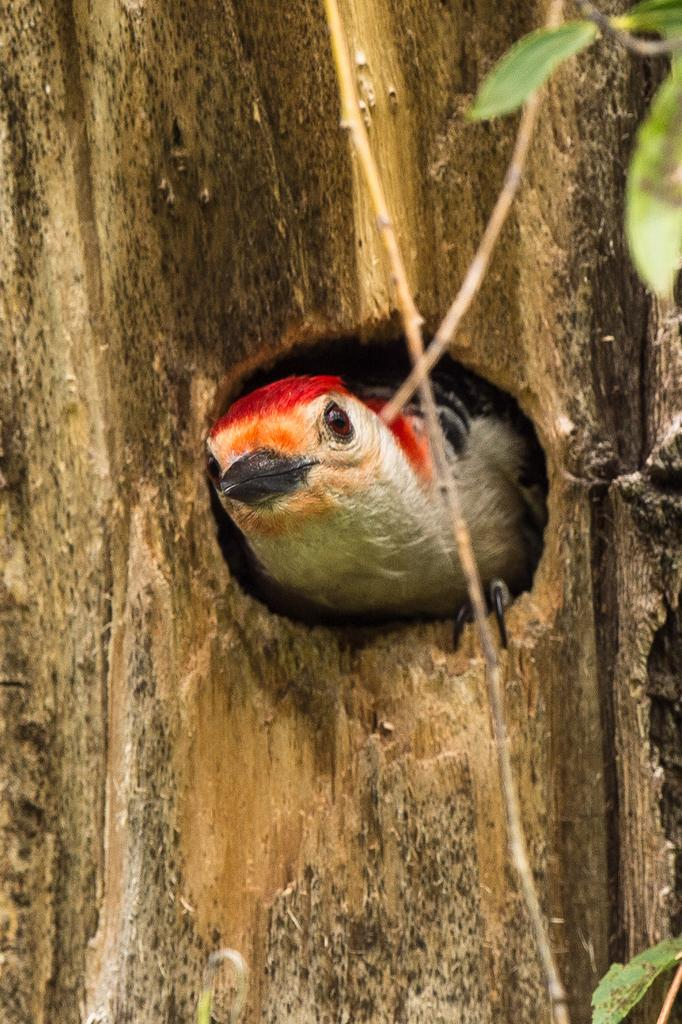What type of animal can be seen in the image? There is a bird in the image. Where is the bird located? The bird is on a tree trunk. What else can be seen in the image besides the bird? There are leaves visible in the image. What type of nut is the bird rubbing on the tree trunk in the image? There is no nut present in the image, nor is the bird rubbing anything on the tree trunk. 